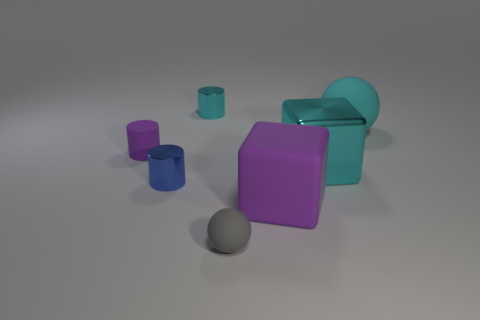Add 3 tiny blue blocks. How many objects exist? 10 Subtract all cubes. How many objects are left? 5 Add 1 tiny purple rubber things. How many tiny purple rubber things are left? 2 Add 5 tiny gray rubber balls. How many tiny gray rubber balls exist? 6 Subtract 0 gray cylinders. How many objects are left? 7 Subtract all cubes. Subtract all large things. How many objects are left? 2 